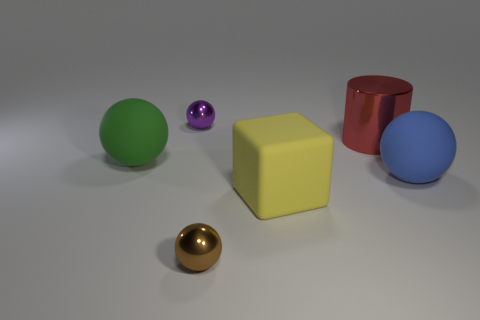There is a object that is in front of the big red metal cylinder and on the right side of the yellow matte object; what size is it?
Make the answer very short. Large. What color is the big sphere that is on the right side of the big green matte thing?
Make the answer very short. Blue. How many other things are there of the same size as the yellow rubber cube?
Your answer should be very brief. 3. Is there anything else that is the same shape as the yellow matte object?
Offer a very short reply. No. Are there the same number of brown metal balls behind the red shiny object and tiny red cubes?
Your answer should be very brief. Yes. How many other tiny things have the same material as the red thing?
Provide a short and direct response. 2. There is a large cylinder that is the same material as the brown object; what is its color?
Your response must be concise. Red. Does the small purple metallic object have the same shape as the big green matte object?
Provide a succinct answer. Yes. Is there a sphere that is on the right side of the metallic ball that is behind the small shiny thing that is in front of the small purple sphere?
Make the answer very short. Yes. What shape is the other metallic object that is the same size as the green object?
Keep it short and to the point. Cylinder. 